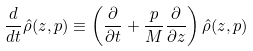Convert formula to latex. <formula><loc_0><loc_0><loc_500><loc_500>\frac { d } { d t } \hat { \rho } ( z , p ) \equiv \left ( \frac { \partial } { \partial t } + \frac { p } { M } \frac { \partial } { \partial z } \right ) \hat { \rho } ( z , p )</formula> 